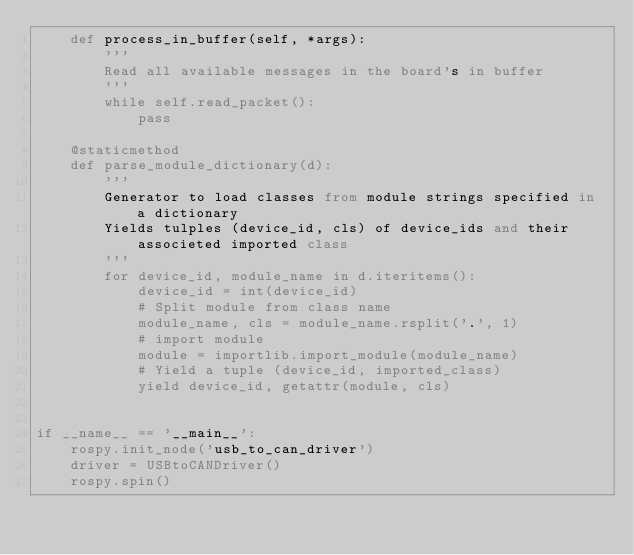<code> <loc_0><loc_0><loc_500><loc_500><_Python_>    def process_in_buffer(self, *args):
        '''
        Read all available messages in the board's in buffer
        '''
        while self.read_packet():
            pass

    @staticmethod
    def parse_module_dictionary(d):
        '''
        Generator to load classes from module strings specified in a dictionary
        Yields tulples (device_id, cls) of device_ids and their associeted imported class
        '''
        for device_id, module_name in d.iteritems():
            device_id = int(device_id)
            # Split module from class name
            module_name, cls = module_name.rsplit('.', 1)
            # import module
            module = importlib.import_module(module_name)
            # Yield a tuple (device_id, imported_class)
            yield device_id, getattr(module, cls)


if __name__ == '__main__':
    rospy.init_node('usb_to_can_driver')
    driver = USBtoCANDriver()
    rospy.spin()
</code> 